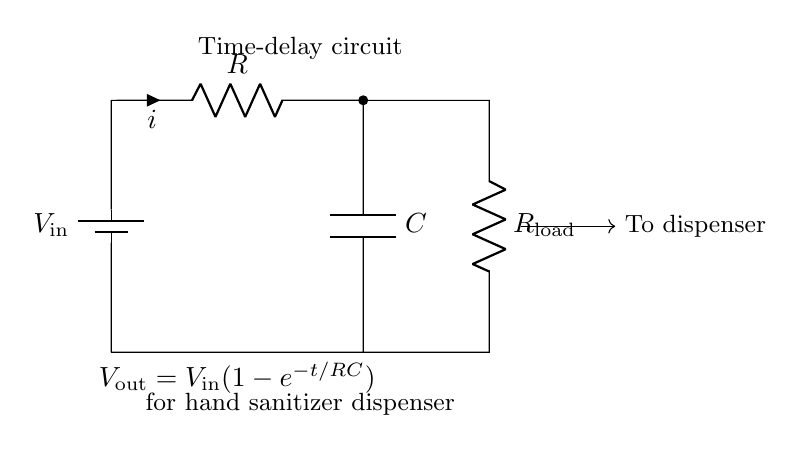What is the type of circuit represented? The circuit is a resistor-capacitor or RC circuit, which typically consists of a resistor and a capacitor connected in a specific configuration to create a time delay.
Answer: RC circuit What is the output voltage expression? The output voltage expression is given as V out = V in(1-e^(-t/RC)), indicating how the output voltage responds over time based on the resistor and capacitor values.
Answer: V out = V in(1-e^(-t/RC)) What is the role of the capacitor in this circuit? The capacitor stores electrical energy and releases it, which contributes to the time-delay feature of the circuit by allowing the output voltage to rise gradually rather than instantly.
Answer: Time delay What determines the time constant of the circuit? The time constant of the circuit is determined by the product of the resistance R and the capacitance C, represented as τ = R*C. It indicates how quickly the capacitor charges.
Answer: R*C What would happen if the resistance value is increased? Increasing the resistance value R would increase the time constant, causing the capacitor to charge more slowly and thereby increasing the time delay before the output voltage reaches a specific level.
Answer: Increases time delay Which component is responsible for the load in this circuit? The load in this circuit is represented by the additional resistor labeled R load, which is connected in parallel with the capacitor and contributes to the overall behavior of the circuit.
Answer: R load 